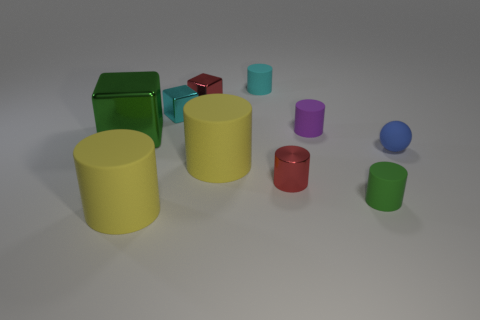Is there a tiny purple thing of the same shape as the tiny cyan metallic object? no 